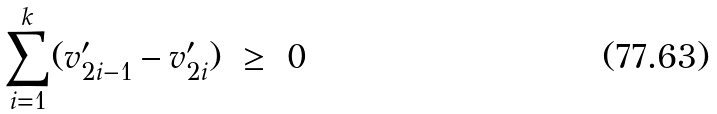Convert formula to latex. <formula><loc_0><loc_0><loc_500><loc_500>\sum _ { i = 1 } ^ { k } ( v _ { 2 i - 1 } ^ { \prime } - v ^ { \prime } _ { 2 i } ) \ \geq \ 0</formula> 